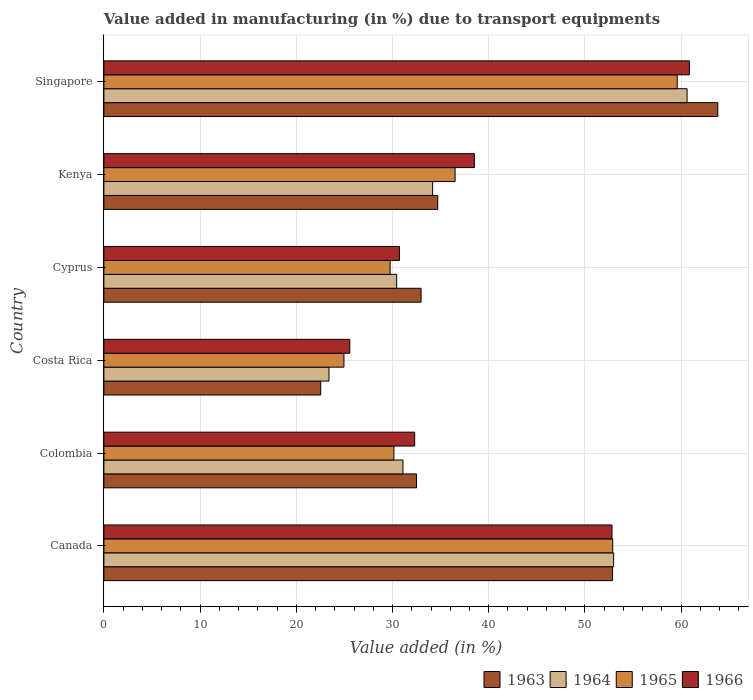How many bars are there on the 5th tick from the top?
Keep it short and to the point. 4. What is the label of the 6th group of bars from the top?
Offer a very short reply. Canada. What is the percentage of value added in manufacturing due to transport equipments in 1966 in Kenya?
Provide a succinct answer. 38.51. Across all countries, what is the maximum percentage of value added in manufacturing due to transport equipments in 1965?
Ensure brevity in your answer.  59.59. Across all countries, what is the minimum percentage of value added in manufacturing due to transport equipments in 1965?
Your answer should be very brief. 24.95. In which country was the percentage of value added in manufacturing due to transport equipments in 1965 maximum?
Offer a terse response. Singapore. In which country was the percentage of value added in manufacturing due to transport equipments in 1966 minimum?
Provide a succinct answer. Costa Rica. What is the total percentage of value added in manufacturing due to transport equipments in 1965 in the graph?
Keep it short and to the point. 233.83. What is the difference between the percentage of value added in manufacturing due to transport equipments in 1963 in Canada and that in Kenya?
Keep it short and to the point. 18.17. What is the difference between the percentage of value added in manufacturing due to transport equipments in 1964 in Costa Rica and the percentage of value added in manufacturing due to transport equipments in 1963 in Singapore?
Ensure brevity in your answer.  -40.41. What is the average percentage of value added in manufacturing due to transport equipments in 1966 per country?
Offer a terse response. 40.13. What is the difference between the percentage of value added in manufacturing due to transport equipments in 1966 and percentage of value added in manufacturing due to transport equipments in 1965 in Cyprus?
Offer a terse response. 0.96. In how many countries, is the percentage of value added in manufacturing due to transport equipments in 1963 greater than 6 %?
Ensure brevity in your answer.  6. What is the ratio of the percentage of value added in manufacturing due to transport equipments in 1963 in Canada to that in Colombia?
Your answer should be very brief. 1.63. Is the percentage of value added in manufacturing due to transport equipments in 1966 in Costa Rica less than that in Singapore?
Provide a succinct answer. Yes. What is the difference between the highest and the second highest percentage of value added in manufacturing due to transport equipments in 1965?
Offer a very short reply. 6.71. What is the difference between the highest and the lowest percentage of value added in manufacturing due to transport equipments in 1965?
Provide a succinct answer. 34.64. Is it the case that in every country, the sum of the percentage of value added in manufacturing due to transport equipments in 1965 and percentage of value added in manufacturing due to transport equipments in 1966 is greater than the sum of percentage of value added in manufacturing due to transport equipments in 1963 and percentage of value added in manufacturing due to transport equipments in 1964?
Your answer should be compact. No. What does the 1st bar from the top in Kenya represents?
Ensure brevity in your answer.  1966. Is it the case that in every country, the sum of the percentage of value added in manufacturing due to transport equipments in 1964 and percentage of value added in manufacturing due to transport equipments in 1965 is greater than the percentage of value added in manufacturing due to transport equipments in 1963?
Offer a terse response. Yes. How many bars are there?
Offer a very short reply. 24. Are all the bars in the graph horizontal?
Your answer should be compact. Yes. How many countries are there in the graph?
Make the answer very short. 6. Are the values on the major ticks of X-axis written in scientific E-notation?
Offer a very short reply. No. What is the title of the graph?
Provide a short and direct response. Value added in manufacturing (in %) due to transport equipments. Does "1971" appear as one of the legend labels in the graph?
Make the answer very short. No. What is the label or title of the X-axis?
Make the answer very short. Value added (in %). What is the label or title of the Y-axis?
Your response must be concise. Country. What is the Value added (in %) in 1963 in Canada?
Offer a very short reply. 52.87. What is the Value added (in %) of 1964 in Canada?
Your answer should be very brief. 52.98. What is the Value added (in %) in 1965 in Canada?
Your answer should be compact. 52.89. What is the Value added (in %) in 1966 in Canada?
Your answer should be very brief. 52.81. What is the Value added (in %) of 1963 in Colombia?
Ensure brevity in your answer.  32.49. What is the Value added (in %) in 1964 in Colombia?
Ensure brevity in your answer.  31.09. What is the Value added (in %) of 1965 in Colombia?
Provide a succinct answer. 30.15. What is the Value added (in %) of 1966 in Colombia?
Your answer should be very brief. 32.3. What is the Value added (in %) in 1963 in Costa Rica?
Offer a terse response. 22.53. What is the Value added (in %) in 1964 in Costa Rica?
Your response must be concise. 23.4. What is the Value added (in %) in 1965 in Costa Rica?
Your answer should be very brief. 24.95. What is the Value added (in %) in 1966 in Costa Rica?
Ensure brevity in your answer.  25.56. What is the Value added (in %) of 1963 in Cyprus?
Make the answer very short. 32.97. What is the Value added (in %) of 1964 in Cyprus?
Your answer should be compact. 30.43. What is the Value added (in %) of 1965 in Cyprus?
Give a very brief answer. 29.75. What is the Value added (in %) of 1966 in Cyprus?
Ensure brevity in your answer.  30.72. What is the Value added (in %) of 1963 in Kenya?
Make the answer very short. 34.7. What is the Value added (in %) of 1964 in Kenya?
Offer a very short reply. 34.17. What is the Value added (in %) of 1965 in Kenya?
Offer a terse response. 36.5. What is the Value added (in %) in 1966 in Kenya?
Your answer should be very brief. 38.51. What is the Value added (in %) of 1963 in Singapore?
Your answer should be very brief. 63.81. What is the Value added (in %) in 1964 in Singapore?
Your answer should be compact. 60.62. What is the Value added (in %) of 1965 in Singapore?
Your answer should be compact. 59.59. What is the Value added (in %) of 1966 in Singapore?
Offer a very short reply. 60.86. Across all countries, what is the maximum Value added (in %) of 1963?
Ensure brevity in your answer.  63.81. Across all countries, what is the maximum Value added (in %) in 1964?
Keep it short and to the point. 60.62. Across all countries, what is the maximum Value added (in %) of 1965?
Your response must be concise. 59.59. Across all countries, what is the maximum Value added (in %) of 1966?
Ensure brevity in your answer.  60.86. Across all countries, what is the minimum Value added (in %) of 1963?
Offer a terse response. 22.53. Across all countries, what is the minimum Value added (in %) in 1964?
Offer a terse response. 23.4. Across all countries, what is the minimum Value added (in %) in 1965?
Your answer should be very brief. 24.95. Across all countries, what is the minimum Value added (in %) of 1966?
Ensure brevity in your answer.  25.56. What is the total Value added (in %) of 1963 in the graph?
Give a very brief answer. 239.38. What is the total Value added (in %) in 1964 in the graph?
Your response must be concise. 232.68. What is the total Value added (in %) in 1965 in the graph?
Offer a terse response. 233.83. What is the total Value added (in %) in 1966 in the graph?
Your answer should be compact. 240.76. What is the difference between the Value added (in %) in 1963 in Canada and that in Colombia?
Make the answer very short. 20.38. What is the difference between the Value added (in %) in 1964 in Canada and that in Colombia?
Make the answer very short. 21.9. What is the difference between the Value added (in %) in 1965 in Canada and that in Colombia?
Provide a short and direct response. 22.74. What is the difference between the Value added (in %) in 1966 in Canada and that in Colombia?
Provide a short and direct response. 20.51. What is the difference between the Value added (in %) of 1963 in Canada and that in Costa Rica?
Your answer should be very brief. 30.34. What is the difference between the Value added (in %) in 1964 in Canada and that in Costa Rica?
Keep it short and to the point. 29.59. What is the difference between the Value added (in %) of 1965 in Canada and that in Costa Rica?
Provide a succinct answer. 27.93. What is the difference between the Value added (in %) of 1966 in Canada and that in Costa Rica?
Give a very brief answer. 27.25. What is the difference between the Value added (in %) in 1963 in Canada and that in Cyprus?
Offer a very short reply. 19.91. What is the difference between the Value added (in %) of 1964 in Canada and that in Cyprus?
Offer a very short reply. 22.55. What is the difference between the Value added (in %) in 1965 in Canada and that in Cyprus?
Provide a short and direct response. 23.13. What is the difference between the Value added (in %) in 1966 in Canada and that in Cyprus?
Make the answer very short. 22.1. What is the difference between the Value added (in %) in 1963 in Canada and that in Kenya?
Make the answer very short. 18.17. What is the difference between the Value added (in %) of 1964 in Canada and that in Kenya?
Your answer should be compact. 18.81. What is the difference between the Value added (in %) in 1965 in Canada and that in Kenya?
Offer a very short reply. 16.38. What is the difference between the Value added (in %) of 1966 in Canada and that in Kenya?
Ensure brevity in your answer.  14.3. What is the difference between the Value added (in %) of 1963 in Canada and that in Singapore?
Keep it short and to the point. -10.94. What is the difference between the Value added (in %) of 1964 in Canada and that in Singapore?
Offer a terse response. -7.63. What is the difference between the Value added (in %) in 1965 in Canada and that in Singapore?
Your answer should be compact. -6.71. What is the difference between the Value added (in %) of 1966 in Canada and that in Singapore?
Your answer should be very brief. -8.05. What is the difference between the Value added (in %) in 1963 in Colombia and that in Costa Rica?
Your answer should be very brief. 9.96. What is the difference between the Value added (in %) of 1964 in Colombia and that in Costa Rica?
Your answer should be very brief. 7.69. What is the difference between the Value added (in %) in 1965 in Colombia and that in Costa Rica?
Ensure brevity in your answer.  5.2. What is the difference between the Value added (in %) in 1966 in Colombia and that in Costa Rica?
Offer a terse response. 6.74. What is the difference between the Value added (in %) of 1963 in Colombia and that in Cyprus?
Ensure brevity in your answer.  -0.47. What is the difference between the Value added (in %) in 1964 in Colombia and that in Cyprus?
Offer a terse response. 0.66. What is the difference between the Value added (in %) of 1965 in Colombia and that in Cyprus?
Your response must be concise. 0.39. What is the difference between the Value added (in %) of 1966 in Colombia and that in Cyprus?
Your answer should be compact. 1.59. What is the difference between the Value added (in %) in 1963 in Colombia and that in Kenya?
Provide a succinct answer. -2.21. What is the difference between the Value added (in %) of 1964 in Colombia and that in Kenya?
Offer a terse response. -3.08. What is the difference between the Value added (in %) in 1965 in Colombia and that in Kenya?
Provide a short and direct response. -6.36. What is the difference between the Value added (in %) in 1966 in Colombia and that in Kenya?
Provide a short and direct response. -6.2. What is the difference between the Value added (in %) in 1963 in Colombia and that in Singapore?
Your answer should be very brief. -31.32. What is the difference between the Value added (in %) of 1964 in Colombia and that in Singapore?
Provide a short and direct response. -29.53. What is the difference between the Value added (in %) in 1965 in Colombia and that in Singapore?
Give a very brief answer. -29.45. What is the difference between the Value added (in %) of 1966 in Colombia and that in Singapore?
Offer a very short reply. -28.56. What is the difference between the Value added (in %) of 1963 in Costa Rica and that in Cyprus?
Your response must be concise. -10.43. What is the difference between the Value added (in %) of 1964 in Costa Rica and that in Cyprus?
Make the answer very short. -7.03. What is the difference between the Value added (in %) of 1965 in Costa Rica and that in Cyprus?
Provide a short and direct response. -4.8. What is the difference between the Value added (in %) of 1966 in Costa Rica and that in Cyprus?
Ensure brevity in your answer.  -5.16. What is the difference between the Value added (in %) in 1963 in Costa Rica and that in Kenya?
Your response must be concise. -12.17. What is the difference between the Value added (in %) in 1964 in Costa Rica and that in Kenya?
Give a very brief answer. -10.77. What is the difference between the Value added (in %) of 1965 in Costa Rica and that in Kenya?
Offer a terse response. -11.55. What is the difference between the Value added (in %) in 1966 in Costa Rica and that in Kenya?
Ensure brevity in your answer.  -12.95. What is the difference between the Value added (in %) of 1963 in Costa Rica and that in Singapore?
Provide a short and direct response. -41.28. What is the difference between the Value added (in %) of 1964 in Costa Rica and that in Singapore?
Your response must be concise. -37.22. What is the difference between the Value added (in %) in 1965 in Costa Rica and that in Singapore?
Give a very brief answer. -34.64. What is the difference between the Value added (in %) in 1966 in Costa Rica and that in Singapore?
Your answer should be very brief. -35.3. What is the difference between the Value added (in %) in 1963 in Cyprus and that in Kenya?
Make the answer very short. -1.73. What is the difference between the Value added (in %) of 1964 in Cyprus and that in Kenya?
Provide a short and direct response. -3.74. What is the difference between the Value added (in %) of 1965 in Cyprus and that in Kenya?
Your answer should be compact. -6.75. What is the difference between the Value added (in %) of 1966 in Cyprus and that in Kenya?
Ensure brevity in your answer.  -7.79. What is the difference between the Value added (in %) in 1963 in Cyprus and that in Singapore?
Your response must be concise. -30.84. What is the difference between the Value added (in %) in 1964 in Cyprus and that in Singapore?
Ensure brevity in your answer.  -30.19. What is the difference between the Value added (in %) in 1965 in Cyprus and that in Singapore?
Your response must be concise. -29.84. What is the difference between the Value added (in %) in 1966 in Cyprus and that in Singapore?
Offer a terse response. -30.14. What is the difference between the Value added (in %) of 1963 in Kenya and that in Singapore?
Your answer should be very brief. -29.11. What is the difference between the Value added (in %) of 1964 in Kenya and that in Singapore?
Your answer should be very brief. -26.45. What is the difference between the Value added (in %) of 1965 in Kenya and that in Singapore?
Provide a succinct answer. -23.09. What is the difference between the Value added (in %) of 1966 in Kenya and that in Singapore?
Ensure brevity in your answer.  -22.35. What is the difference between the Value added (in %) in 1963 in Canada and the Value added (in %) in 1964 in Colombia?
Your answer should be compact. 21.79. What is the difference between the Value added (in %) of 1963 in Canada and the Value added (in %) of 1965 in Colombia?
Offer a terse response. 22.73. What is the difference between the Value added (in %) of 1963 in Canada and the Value added (in %) of 1966 in Colombia?
Ensure brevity in your answer.  20.57. What is the difference between the Value added (in %) of 1964 in Canada and the Value added (in %) of 1965 in Colombia?
Provide a succinct answer. 22.84. What is the difference between the Value added (in %) in 1964 in Canada and the Value added (in %) in 1966 in Colombia?
Your response must be concise. 20.68. What is the difference between the Value added (in %) of 1965 in Canada and the Value added (in %) of 1966 in Colombia?
Offer a very short reply. 20.58. What is the difference between the Value added (in %) in 1963 in Canada and the Value added (in %) in 1964 in Costa Rica?
Your answer should be very brief. 29.48. What is the difference between the Value added (in %) of 1963 in Canada and the Value added (in %) of 1965 in Costa Rica?
Keep it short and to the point. 27.92. What is the difference between the Value added (in %) of 1963 in Canada and the Value added (in %) of 1966 in Costa Rica?
Your answer should be very brief. 27.31. What is the difference between the Value added (in %) of 1964 in Canada and the Value added (in %) of 1965 in Costa Rica?
Offer a terse response. 28.03. What is the difference between the Value added (in %) in 1964 in Canada and the Value added (in %) in 1966 in Costa Rica?
Provide a short and direct response. 27.42. What is the difference between the Value added (in %) in 1965 in Canada and the Value added (in %) in 1966 in Costa Rica?
Offer a terse response. 27.33. What is the difference between the Value added (in %) of 1963 in Canada and the Value added (in %) of 1964 in Cyprus?
Provide a short and direct response. 22.44. What is the difference between the Value added (in %) in 1963 in Canada and the Value added (in %) in 1965 in Cyprus?
Provide a short and direct response. 23.12. What is the difference between the Value added (in %) of 1963 in Canada and the Value added (in %) of 1966 in Cyprus?
Your answer should be compact. 22.16. What is the difference between the Value added (in %) in 1964 in Canada and the Value added (in %) in 1965 in Cyprus?
Offer a very short reply. 23.23. What is the difference between the Value added (in %) in 1964 in Canada and the Value added (in %) in 1966 in Cyprus?
Your answer should be very brief. 22.27. What is the difference between the Value added (in %) of 1965 in Canada and the Value added (in %) of 1966 in Cyprus?
Provide a succinct answer. 22.17. What is the difference between the Value added (in %) in 1963 in Canada and the Value added (in %) in 1964 in Kenya?
Offer a very short reply. 18.7. What is the difference between the Value added (in %) of 1963 in Canada and the Value added (in %) of 1965 in Kenya?
Offer a very short reply. 16.37. What is the difference between the Value added (in %) of 1963 in Canada and the Value added (in %) of 1966 in Kenya?
Your answer should be very brief. 14.37. What is the difference between the Value added (in %) in 1964 in Canada and the Value added (in %) in 1965 in Kenya?
Your answer should be very brief. 16.48. What is the difference between the Value added (in %) of 1964 in Canada and the Value added (in %) of 1966 in Kenya?
Your answer should be compact. 14.47. What is the difference between the Value added (in %) of 1965 in Canada and the Value added (in %) of 1966 in Kenya?
Your answer should be very brief. 14.38. What is the difference between the Value added (in %) of 1963 in Canada and the Value added (in %) of 1964 in Singapore?
Give a very brief answer. -7.74. What is the difference between the Value added (in %) of 1963 in Canada and the Value added (in %) of 1965 in Singapore?
Keep it short and to the point. -6.72. What is the difference between the Value added (in %) of 1963 in Canada and the Value added (in %) of 1966 in Singapore?
Provide a succinct answer. -7.99. What is the difference between the Value added (in %) in 1964 in Canada and the Value added (in %) in 1965 in Singapore?
Your answer should be very brief. -6.61. What is the difference between the Value added (in %) in 1964 in Canada and the Value added (in %) in 1966 in Singapore?
Offer a very short reply. -7.88. What is the difference between the Value added (in %) of 1965 in Canada and the Value added (in %) of 1966 in Singapore?
Your answer should be very brief. -7.97. What is the difference between the Value added (in %) in 1963 in Colombia and the Value added (in %) in 1964 in Costa Rica?
Your answer should be very brief. 9.1. What is the difference between the Value added (in %) in 1963 in Colombia and the Value added (in %) in 1965 in Costa Rica?
Give a very brief answer. 7.54. What is the difference between the Value added (in %) in 1963 in Colombia and the Value added (in %) in 1966 in Costa Rica?
Provide a succinct answer. 6.93. What is the difference between the Value added (in %) of 1964 in Colombia and the Value added (in %) of 1965 in Costa Rica?
Ensure brevity in your answer.  6.14. What is the difference between the Value added (in %) in 1964 in Colombia and the Value added (in %) in 1966 in Costa Rica?
Your response must be concise. 5.53. What is the difference between the Value added (in %) in 1965 in Colombia and the Value added (in %) in 1966 in Costa Rica?
Offer a terse response. 4.59. What is the difference between the Value added (in %) of 1963 in Colombia and the Value added (in %) of 1964 in Cyprus?
Offer a terse response. 2.06. What is the difference between the Value added (in %) in 1963 in Colombia and the Value added (in %) in 1965 in Cyprus?
Your response must be concise. 2.74. What is the difference between the Value added (in %) of 1963 in Colombia and the Value added (in %) of 1966 in Cyprus?
Your response must be concise. 1.78. What is the difference between the Value added (in %) in 1964 in Colombia and the Value added (in %) in 1965 in Cyprus?
Provide a succinct answer. 1.33. What is the difference between the Value added (in %) in 1964 in Colombia and the Value added (in %) in 1966 in Cyprus?
Your answer should be compact. 0.37. What is the difference between the Value added (in %) in 1965 in Colombia and the Value added (in %) in 1966 in Cyprus?
Your response must be concise. -0.57. What is the difference between the Value added (in %) in 1963 in Colombia and the Value added (in %) in 1964 in Kenya?
Keep it short and to the point. -1.68. What is the difference between the Value added (in %) of 1963 in Colombia and the Value added (in %) of 1965 in Kenya?
Ensure brevity in your answer.  -4.01. What is the difference between the Value added (in %) in 1963 in Colombia and the Value added (in %) in 1966 in Kenya?
Your response must be concise. -6.01. What is the difference between the Value added (in %) in 1964 in Colombia and the Value added (in %) in 1965 in Kenya?
Offer a terse response. -5.42. What is the difference between the Value added (in %) in 1964 in Colombia and the Value added (in %) in 1966 in Kenya?
Your response must be concise. -7.42. What is the difference between the Value added (in %) in 1965 in Colombia and the Value added (in %) in 1966 in Kenya?
Offer a very short reply. -8.36. What is the difference between the Value added (in %) of 1963 in Colombia and the Value added (in %) of 1964 in Singapore?
Your answer should be compact. -28.12. What is the difference between the Value added (in %) in 1963 in Colombia and the Value added (in %) in 1965 in Singapore?
Your answer should be very brief. -27.1. What is the difference between the Value added (in %) of 1963 in Colombia and the Value added (in %) of 1966 in Singapore?
Your answer should be compact. -28.37. What is the difference between the Value added (in %) of 1964 in Colombia and the Value added (in %) of 1965 in Singapore?
Your response must be concise. -28.51. What is the difference between the Value added (in %) of 1964 in Colombia and the Value added (in %) of 1966 in Singapore?
Ensure brevity in your answer.  -29.77. What is the difference between the Value added (in %) in 1965 in Colombia and the Value added (in %) in 1966 in Singapore?
Offer a very short reply. -30.71. What is the difference between the Value added (in %) of 1963 in Costa Rica and the Value added (in %) of 1964 in Cyprus?
Give a very brief answer. -7.9. What is the difference between the Value added (in %) of 1963 in Costa Rica and the Value added (in %) of 1965 in Cyprus?
Keep it short and to the point. -7.22. What is the difference between the Value added (in %) of 1963 in Costa Rica and the Value added (in %) of 1966 in Cyprus?
Offer a very short reply. -8.18. What is the difference between the Value added (in %) of 1964 in Costa Rica and the Value added (in %) of 1965 in Cyprus?
Provide a succinct answer. -6.36. What is the difference between the Value added (in %) in 1964 in Costa Rica and the Value added (in %) in 1966 in Cyprus?
Offer a very short reply. -7.32. What is the difference between the Value added (in %) in 1965 in Costa Rica and the Value added (in %) in 1966 in Cyprus?
Your answer should be very brief. -5.77. What is the difference between the Value added (in %) of 1963 in Costa Rica and the Value added (in %) of 1964 in Kenya?
Offer a very short reply. -11.64. What is the difference between the Value added (in %) of 1963 in Costa Rica and the Value added (in %) of 1965 in Kenya?
Your answer should be very brief. -13.97. What is the difference between the Value added (in %) of 1963 in Costa Rica and the Value added (in %) of 1966 in Kenya?
Provide a succinct answer. -15.97. What is the difference between the Value added (in %) of 1964 in Costa Rica and the Value added (in %) of 1965 in Kenya?
Make the answer very short. -13.11. What is the difference between the Value added (in %) of 1964 in Costa Rica and the Value added (in %) of 1966 in Kenya?
Provide a short and direct response. -15.11. What is the difference between the Value added (in %) in 1965 in Costa Rica and the Value added (in %) in 1966 in Kenya?
Make the answer very short. -13.56. What is the difference between the Value added (in %) of 1963 in Costa Rica and the Value added (in %) of 1964 in Singapore?
Keep it short and to the point. -38.08. What is the difference between the Value added (in %) in 1963 in Costa Rica and the Value added (in %) in 1965 in Singapore?
Offer a very short reply. -37.06. What is the difference between the Value added (in %) of 1963 in Costa Rica and the Value added (in %) of 1966 in Singapore?
Make the answer very short. -38.33. What is the difference between the Value added (in %) of 1964 in Costa Rica and the Value added (in %) of 1965 in Singapore?
Your answer should be compact. -36.19. What is the difference between the Value added (in %) in 1964 in Costa Rica and the Value added (in %) in 1966 in Singapore?
Make the answer very short. -37.46. What is the difference between the Value added (in %) of 1965 in Costa Rica and the Value added (in %) of 1966 in Singapore?
Ensure brevity in your answer.  -35.91. What is the difference between the Value added (in %) of 1963 in Cyprus and the Value added (in %) of 1964 in Kenya?
Keep it short and to the point. -1.2. What is the difference between the Value added (in %) of 1963 in Cyprus and the Value added (in %) of 1965 in Kenya?
Your response must be concise. -3.54. What is the difference between the Value added (in %) of 1963 in Cyprus and the Value added (in %) of 1966 in Kenya?
Your response must be concise. -5.54. What is the difference between the Value added (in %) of 1964 in Cyprus and the Value added (in %) of 1965 in Kenya?
Make the answer very short. -6.07. What is the difference between the Value added (in %) of 1964 in Cyprus and the Value added (in %) of 1966 in Kenya?
Make the answer very short. -8.08. What is the difference between the Value added (in %) in 1965 in Cyprus and the Value added (in %) in 1966 in Kenya?
Provide a succinct answer. -8.75. What is the difference between the Value added (in %) of 1963 in Cyprus and the Value added (in %) of 1964 in Singapore?
Your answer should be very brief. -27.65. What is the difference between the Value added (in %) in 1963 in Cyprus and the Value added (in %) in 1965 in Singapore?
Keep it short and to the point. -26.62. What is the difference between the Value added (in %) of 1963 in Cyprus and the Value added (in %) of 1966 in Singapore?
Your answer should be very brief. -27.89. What is the difference between the Value added (in %) in 1964 in Cyprus and the Value added (in %) in 1965 in Singapore?
Your response must be concise. -29.16. What is the difference between the Value added (in %) of 1964 in Cyprus and the Value added (in %) of 1966 in Singapore?
Your answer should be very brief. -30.43. What is the difference between the Value added (in %) in 1965 in Cyprus and the Value added (in %) in 1966 in Singapore?
Ensure brevity in your answer.  -31.11. What is the difference between the Value added (in %) of 1963 in Kenya and the Value added (in %) of 1964 in Singapore?
Ensure brevity in your answer.  -25.92. What is the difference between the Value added (in %) of 1963 in Kenya and the Value added (in %) of 1965 in Singapore?
Provide a succinct answer. -24.89. What is the difference between the Value added (in %) in 1963 in Kenya and the Value added (in %) in 1966 in Singapore?
Give a very brief answer. -26.16. What is the difference between the Value added (in %) of 1964 in Kenya and the Value added (in %) of 1965 in Singapore?
Keep it short and to the point. -25.42. What is the difference between the Value added (in %) in 1964 in Kenya and the Value added (in %) in 1966 in Singapore?
Make the answer very short. -26.69. What is the difference between the Value added (in %) of 1965 in Kenya and the Value added (in %) of 1966 in Singapore?
Keep it short and to the point. -24.36. What is the average Value added (in %) of 1963 per country?
Your answer should be compact. 39.9. What is the average Value added (in %) in 1964 per country?
Ensure brevity in your answer.  38.78. What is the average Value added (in %) of 1965 per country?
Your response must be concise. 38.97. What is the average Value added (in %) of 1966 per country?
Provide a succinct answer. 40.13. What is the difference between the Value added (in %) in 1963 and Value added (in %) in 1964 in Canada?
Offer a very short reply. -0.11. What is the difference between the Value added (in %) of 1963 and Value added (in %) of 1965 in Canada?
Provide a succinct answer. -0.01. What is the difference between the Value added (in %) of 1963 and Value added (in %) of 1966 in Canada?
Provide a short and direct response. 0.06. What is the difference between the Value added (in %) in 1964 and Value added (in %) in 1965 in Canada?
Your answer should be very brief. 0.1. What is the difference between the Value added (in %) in 1964 and Value added (in %) in 1966 in Canada?
Give a very brief answer. 0.17. What is the difference between the Value added (in %) in 1965 and Value added (in %) in 1966 in Canada?
Keep it short and to the point. 0.07. What is the difference between the Value added (in %) in 1963 and Value added (in %) in 1964 in Colombia?
Keep it short and to the point. 1.41. What is the difference between the Value added (in %) of 1963 and Value added (in %) of 1965 in Colombia?
Offer a terse response. 2.35. What is the difference between the Value added (in %) of 1963 and Value added (in %) of 1966 in Colombia?
Your answer should be compact. 0.19. What is the difference between the Value added (in %) in 1964 and Value added (in %) in 1965 in Colombia?
Offer a very short reply. 0.94. What is the difference between the Value added (in %) of 1964 and Value added (in %) of 1966 in Colombia?
Provide a succinct answer. -1.22. What is the difference between the Value added (in %) in 1965 and Value added (in %) in 1966 in Colombia?
Provide a succinct answer. -2.16. What is the difference between the Value added (in %) of 1963 and Value added (in %) of 1964 in Costa Rica?
Provide a succinct answer. -0.86. What is the difference between the Value added (in %) of 1963 and Value added (in %) of 1965 in Costa Rica?
Your answer should be compact. -2.42. What is the difference between the Value added (in %) of 1963 and Value added (in %) of 1966 in Costa Rica?
Your answer should be very brief. -3.03. What is the difference between the Value added (in %) in 1964 and Value added (in %) in 1965 in Costa Rica?
Offer a terse response. -1.55. What is the difference between the Value added (in %) of 1964 and Value added (in %) of 1966 in Costa Rica?
Give a very brief answer. -2.16. What is the difference between the Value added (in %) in 1965 and Value added (in %) in 1966 in Costa Rica?
Provide a succinct answer. -0.61. What is the difference between the Value added (in %) of 1963 and Value added (in %) of 1964 in Cyprus?
Provide a succinct answer. 2.54. What is the difference between the Value added (in %) in 1963 and Value added (in %) in 1965 in Cyprus?
Offer a very short reply. 3.21. What is the difference between the Value added (in %) of 1963 and Value added (in %) of 1966 in Cyprus?
Your response must be concise. 2.25. What is the difference between the Value added (in %) in 1964 and Value added (in %) in 1965 in Cyprus?
Ensure brevity in your answer.  0.68. What is the difference between the Value added (in %) in 1964 and Value added (in %) in 1966 in Cyprus?
Ensure brevity in your answer.  -0.29. What is the difference between the Value added (in %) of 1965 and Value added (in %) of 1966 in Cyprus?
Provide a succinct answer. -0.96. What is the difference between the Value added (in %) in 1963 and Value added (in %) in 1964 in Kenya?
Your answer should be very brief. 0.53. What is the difference between the Value added (in %) in 1963 and Value added (in %) in 1965 in Kenya?
Give a very brief answer. -1.8. What is the difference between the Value added (in %) in 1963 and Value added (in %) in 1966 in Kenya?
Ensure brevity in your answer.  -3.81. What is the difference between the Value added (in %) of 1964 and Value added (in %) of 1965 in Kenya?
Give a very brief answer. -2.33. What is the difference between the Value added (in %) of 1964 and Value added (in %) of 1966 in Kenya?
Provide a short and direct response. -4.34. What is the difference between the Value added (in %) in 1965 and Value added (in %) in 1966 in Kenya?
Ensure brevity in your answer.  -2. What is the difference between the Value added (in %) of 1963 and Value added (in %) of 1964 in Singapore?
Your response must be concise. 3.19. What is the difference between the Value added (in %) in 1963 and Value added (in %) in 1965 in Singapore?
Offer a terse response. 4.22. What is the difference between the Value added (in %) in 1963 and Value added (in %) in 1966 in Singapore?
Ensure brevity in your answer.  2.95. What is the difference between the Value added (in %) of 1964 and Value added (in %) of 1965 in Singapore?
Make the answer very short. 1.03. What is the difference between the Value added (in %) of 1964 and Value added (in %) of 1966 in Singapore?
Offer a very short reply. -0.24. What is the difference between the Value added (in %) in 1965 and Value added (in %) in 1966 in Singapore?
Provide a succinct answer. -1.27. What is the ratio of the Value added (in %) in 1963 in Canada to that in Colombia?
Your response must be concise. 1.63. What is the ratio of the Value added (in %) of 1964 in Canada to that in Colombia?
Provide a succinct answer. 1.7. What is the ratio of the Value added (in %) in 1965 in Canada to that in Colombia?
Ensure brevity in your answer.  1.75. What is the ratio of the Value added (in %) in 1966 in Canada to that in Colombia?
Keep it short and to the point. 1.63. What is the ratio of the Value added (in %) of 1963 in Canada to that in Costa Rica?
Offer a terse response. 2.35. What is the ratio of the Value added (in %) in 1964 in Canada to that in Costa Rica?
Offer a very short reply. 2.26. What is the ratio of the Value added (in %) of 1965 in Canada to that in Costa Rica?
Give a very brief answer. 2.12. What is the ratio of the Value added (in %) of 1966 in Canada to that in Costa Rica?
Make the answer very short. 2.07. What is the ratio of the Value added (in %) of 1963 in Canada to that in Cyprus?
Your answer should be very brief. 1.6. What is the ratio of the Value added (in %) in 1964 in Canada to that in Cyprus?
Give a very brief answer. 1.74. What is the ratio of the Value added (in %) in 1965 in Canada to that in Cyprus?
Ensure brevity in your answer.  1.78. What is the ratio of the Value added (in %) of 1966 in Canada to that in Cyprus?
Give a very brief answer. 1.72. What is the ratio of the Value added (in %) in 1963 in Canada to that in Kenya?
Your answer should be compact. 1.52. What is the ratio of the Value added (in %) of 1964 in Canada to that in Kenya?
Give a very brief answer. 1.55. What is the ratio of the Value added (in %) in 1965 in Canada to that in Kenya?
Offer a very short reply. 1.45. What is the ratio of the Value added (in %) in 1966 in Canada to that in Kenya?
Your answer should be very brief. 1.37. What is the ratio of the Value added (in %) of 1963 in Canada to that in Singapore?
Provide a short and direct response. 0.83. What is the ratio of the Value added (in %) in 1964 in Canada to that in Singapore?
Your answer should be very brief. 0.87. What is the ratio of the Value added (in %) in 1965 in Canada to that in Singapore?
Provide a succinct answer. 0.89. What is the ratio of the Value added (in %) of 1966 in Canada to that in Singapore?
Your answer should be very brief. 0.87. What is the ratio of the Value added (in %) of 1963 in Colombia to that in Costa Rica?
Offer a terse response. 1.44. What is the ratio of the Value added (in %) of 1964 in Colombia to that in Costa Rica?
Ensure brevity in your answer.  1.33. What is the ratio of the Value added (in %) of 1965 in Colombia to that in Costa Rica?
Give a very brief answer. 1.21. What is the ratio of the Value added (in %) in 1966 in Colombia to that in Costa Rica?
Provide a short and direct response. 1.26. What is the ratio of the Value added (in %) of 1963 in Colombia to that in Cyprus?
Make the answer very short. 0.99. What is the ratio of the Value added (in %) in 1964 in Colombia to that in Cyprus?
Offer a very short reply. 1.02. What is the ratio of the Value added (in %) of 1965 in Colombia to that in Cyprus?
Your answer should be very brief. 1.01. What is the ratio of the Value added (in %) of 1966 in Colombia to that in Cyprus?
Make the answer very short. 1.05. What is the ratio of the Value added (in %) of 1963 in Colombia to that in Kenya?
Offer a terse response. 0.94. What is the ratio of the Value added (in %) of 1964 in Colombia to that in Kenya?
Offer a very short reply. 0.91. What is the ratio of the Value added (in %) in 1965 in Colombia to that in Kenya?
Your response must be concise. 0.83. What is the ratio of the Value added (in %) of 1966 in Colombia to that in Kenya?
Provide a succinct answer. 0.84. What is the ratio of the Value added (in %) of 1963 in Colombia to that in Singapore?
Provide a short and direct response. 0.51. What is the ratio of the Value added (in %) in 1964 in Colombia to that in Singapore?
Give a very brief answer. 0.51. What is the ratio of the Value added (in %) in 1965 in Colombia to that in Singapore?
Your response must be concise. 0.51. What is the ratio of the Value added (in %) of 1966 in Colombia to that in Singapore?
Provide a short and direct response. 0.53. What is the ratio of the Value added (in %) of 1963 in Costa Rica to that in Cyprus?
Your response must be concise. 0.68. What is the ratio of the Value added (in %) of 1964 in Costa Rica to that in Cyprus?
Give a very brief answer. 0.77. What is the ratio of the Value added (in %) of 1965 in Costa Rica to that in Cyprus?
Offer a very short reply. 0.84. What is the ratio of the Value added (in %) in 1966 in Costa Rica to that in Cyprus?
Make the answer very short. 0.83. What is the ratio of the Value added (in %) in 1963 in Costa Rica to that in Kenya?
Offer a very short reply. 0.65. What is the ratio of the Value added (in %) in 1964 in Costa Rica to that in Kenya?
Your answer should be compact. 0.68. What is the ratio of the Value added (in %) of 1965 in Costa Rica to that in Kenya?
Your answer should be compact. 0.68. What is the ratio of the Value added (in %) in 1966 in Costa Rica to that in Kenya?
Your response must be concise. 0.66. What is the ratio of the Value added (in %) of 1963 in Costa Rica to that in Singapore?
Provide a succinct answer. 0.35. What is the ratio of the Value added (in %) in 1964 in Costa Rica to that in Singapore?
Provide a short and direct response. 0.39. What is the ratio of the Value added (in %) of 1965 in Costa Rica to that in Singapore?
Your answer should be compact. 0.42. What is the ratio of the Value added (in %) of 1966 in Costa Rica to that in Singapore?
Give a very brief answer. 0.42. What is the ratio of the Value added (in %) in 1963 in Cyprus to that in Kenya?
Your answer should be compact. 0.95. What is the ratio of the Value added (in %) of 1964 in Cyprus to that in Kenya?
Ensure brevity in your answer.  0.89. What is the ratio of the Value added (in %) in 1965 in Cyprus to that in Kenya?
Offer a terse response. 0.82. What is the ratio of the Value added (in %) in 1966 in Cyprus to that in Kenya?
Provide a short and direct response. 0.8. What is the ratio of the Value added (in %) of 1963 in Cyprus to that in Singapore?
Make the answer very short. 0.52. What is the ratio of the Value added (in %) in 1964 in Cyprus to that in Singapore?
Offer a very short reply. 0.5. What is the ratio of the Value added (in %) of 1965 in Cyprus to that in Singapore?
Ensure brevity in your answer.  0.5. What is the ratio of the Value added (in %) of 1966 in Cyprus to that in Singapore?
Provide a short and direct response. 0.5. What is the ratio of the Value added (in %) of 1963 in Kenya to that in Singapore?
Ensure brevity in your answer.  0.54. What is the ratio of the Value added (in %) of 1964 in Kenya to that in Singapore?
Provide a short and direct response. 0.56. What is the ratio of the Value added (in %) in 1965 in Kenya to that in Singapore?
Make the answer very short. 0.61. What is the ratio of the Value added (in %) of 1966 in Kenya to that in Singapore?
Your response must be concise. 0.63. What is the difference between the highest and the second highest Value added (in %) in 1963?
Offer a very short reply. 10.94. What is the difference between the highest and the second highest Value added (in %) in 1964?
Give a very brief answer. 7.63. What is the difference between the highest and the second highest Value added (in %) of 1965?
Make the answer very short. 6.71. What is the difference between the highest and the second highest Value added (in %) of 1966?
Your answer should be very brief. 8.05. What is the difference between the highest and the lowest Value added (in %) in 1963?
Offer a terse response. 41.28. What is the difference between the highest and the lowest Value added (in %) of 1964?
Keep it short and to the point. 37.22. What is the difference between the highest and the lowest Value added (in %) in 1965?
Your answer should be very brief. 34.64. What is the difference between the highest and the lowest Value added (in %) of 1966?
Give a very brief answer. 35.3. 